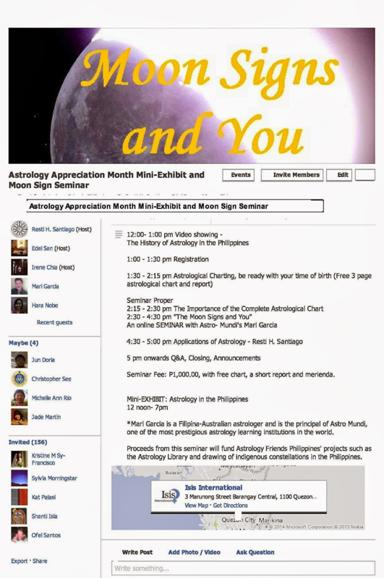What will the proceeds from the seminar be used for? The proceeds raised from the seminar will support the impactful projects of Astrology Friends Philippines, including the creation of an astrology library and the cultural venture of charting indigenous constellations, enriching local astrological heritage. 